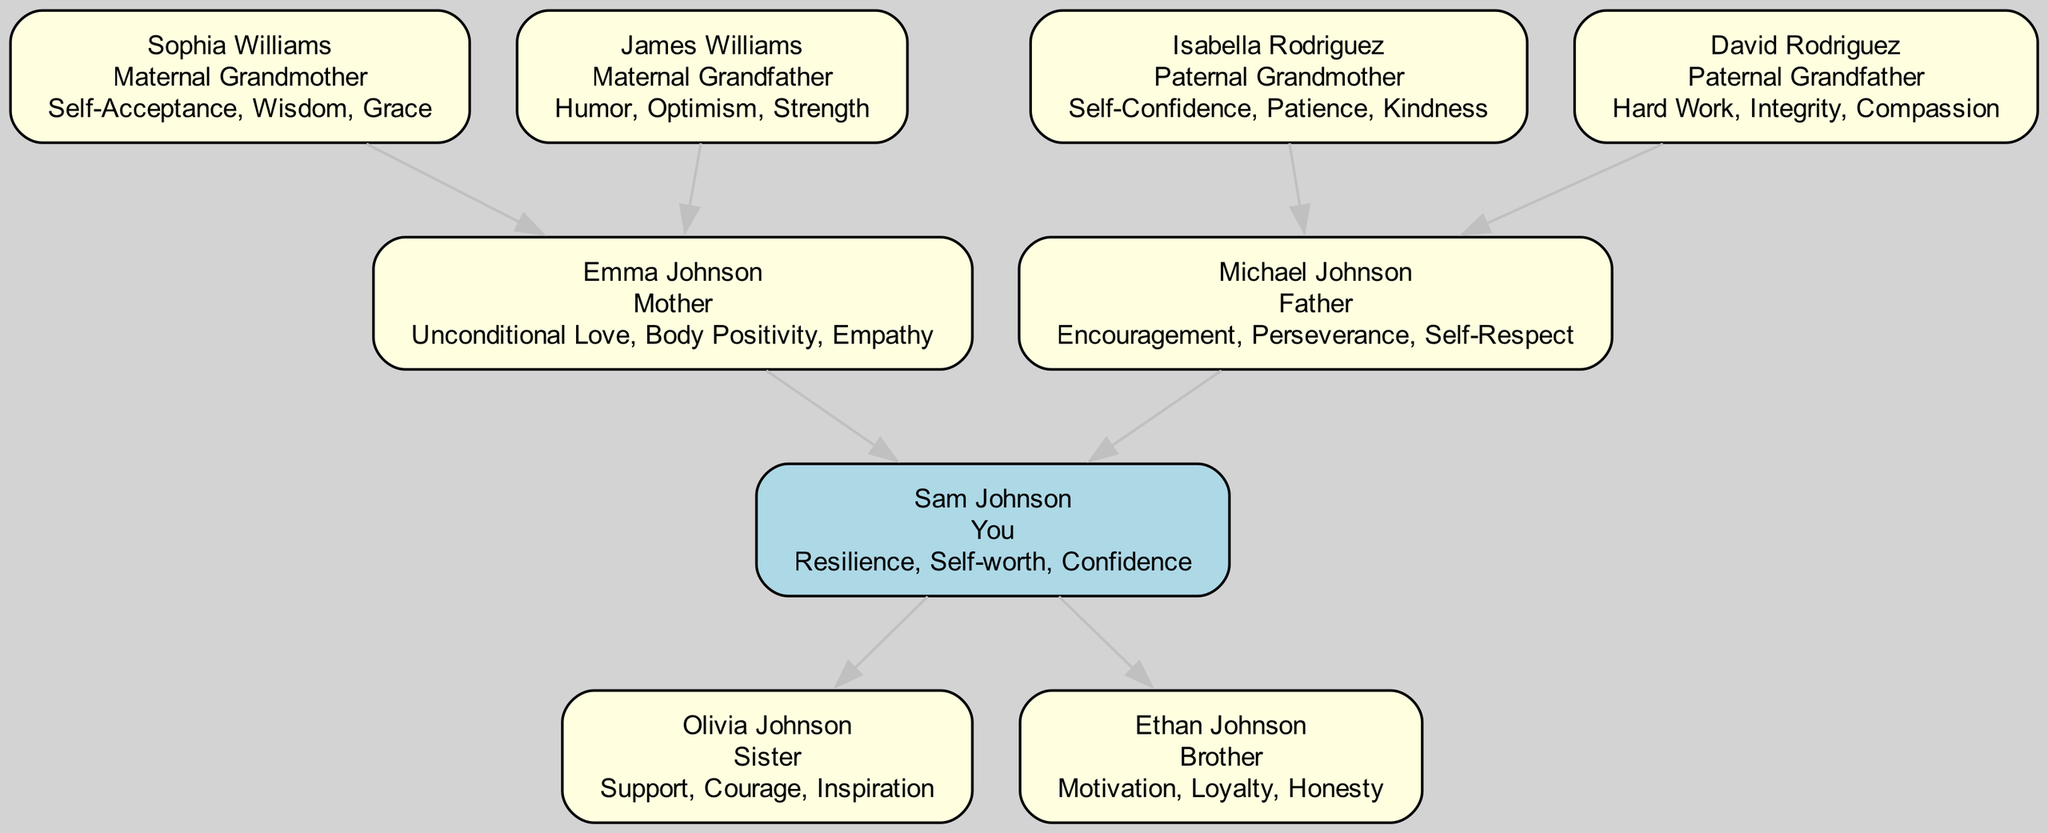What is the name of the root person? The root person is Sam Johnson, identified at the center of the diagram with the label "You" indicating the personal representation.
Answer: Sam Johnson How many support contributions does Sam Johnson have? The root person, Sam Johnson, has three support contributions listed: "Resilience," "Self-worth," "Confidence." Thus, the count of contributions is three.
Answer: 3 Who is the paternal grandmother? The paternal grandmother is named Isabella Rodriguez, as identified from the relationship descriptions in the diagram connected to the paternal branch.
Answer: Isabella Rodriguez What support contribution does Emma Johnson provide? Emma Johnson provides three support contributions: "Unconditional Love," "Body Positivity," and "Empathy." This information is derived from her connection as the Mother in the diagram.
Answer: Unconditional Love, Body Positivity, Empathy How many family members provide contributions related to self-acceptance? The total count of family members contributing to self-acceptance includes Sophie Williams (Maternal Grandmother) and Isabella Rodriguez (Paternal Grandmother). Upon checking the contributions, both are connected to self-acceptance.
Answer: 2 What is the relationship of Ethan Johnson to Sam Johnson? Ethan Johnson is identified directly in the diagram as the "Brother" of Sam Johnson, establishing a clear familial bond.
Answer: Brother Which family member contributes the support of perseverance? Michael Johnson, identified as "Father," contributes the support of "Perseverance," which is specifically listed under his contributions in the diagram.
Answer: Michael Johnson Who has the support contribution of humor? The support contribution of "Humor" is provided by James Williams, identified in the diagram as the "Maternal Grandfather," indicating his role in fostering a positive self-image for Sam Johnson.
Answer: James Williams Which family member has the greatest number of support contributions? When examining the details, both Emma Johnson and Michael Johnson provide three contributions each, but they are the only family members with three contributions listed, making them tied for the most.
Answer: Emma Johnson and Michael Johnson 